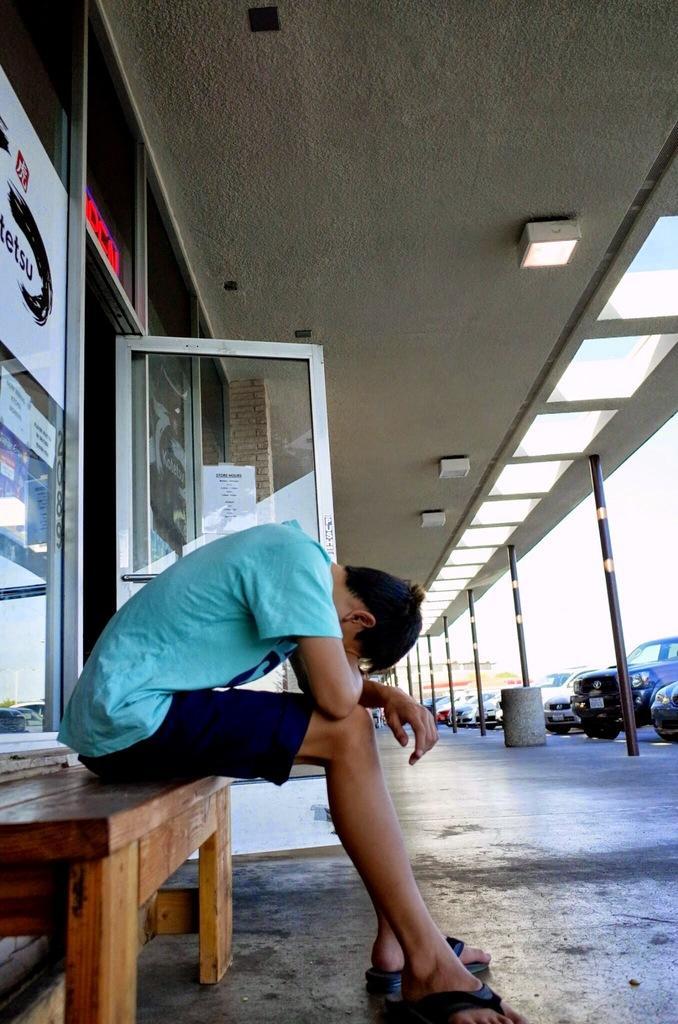In one or two sentences, can you explain what this image depicts? This is the picture of a place where we have a person sitting on the bench and also we can see some cars, poles and some lights to the roof. 